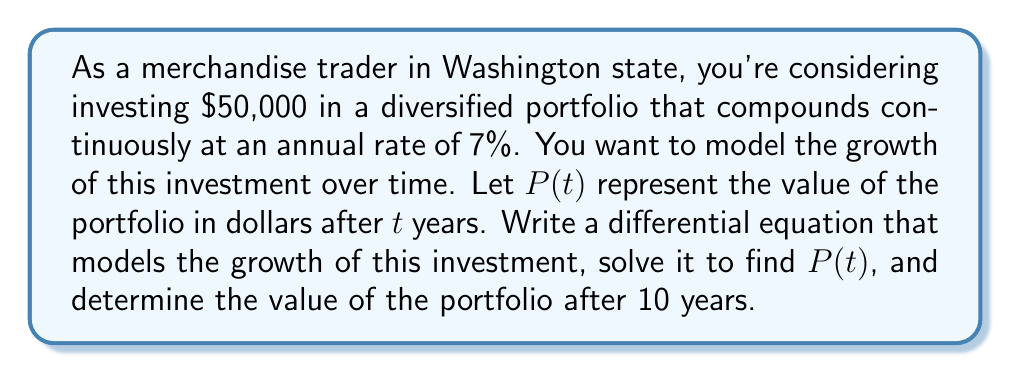Solve this math problem. To model the growth of an investment portfolio with compound interest, we use the following steps:

1) The rate of change of the portfolio value is proportional to the current value of the portfolio. This can be expressed as a differential equation:

   $$\frac{dP}{dt} = rP$$

   where $r$ is the annual interest rate expressed as a decimal.

2) In this case, $r = 0.07$ (7% annual rate), so our differential equation is:

   $$\frac{dP}{dt} = 0.07P$$

3) This is a separable differential equation. We can solve it by separating variables and integrating:

   $$\int \frac{dP}{P} = \int 0.07 dt$$

4) Integrating both sides:

   $$\ln|P| = 0.07t + C$$

   where $C$ is a constant of integration.

5) Exponentiating both sides:

   $$P = e^{0.07t + C} = e^C \cdot e^{0.07t}$$

6) Let $A = e^C$. Then our general solution is:

   $$P(t) = A \cdot e^{0.07t}$$

7) To find $A$, we use the initial condition. At $t = 0$, $P(0) = 50000$:

   $$50000 = A \cdot e^{0.07 \cdot 0} = A$$

8) Therefore, our particular solution is:

   $$P(t) = 50000 \cdot e^{0.07t}$$

9) To find the value after 10 years, we substitute $t = 10$:

   $$P(10) = 50000 \cdot e^{0.07 \cdot 10} = 50000 \cdot e^{0.7} \approx 101022.17$$
Answer: The differential equation modeling the growth is $\frac{dP}{dt} = 0.07P$. The solution is $P(t) = 50000 \cdot e^{0.07t}$. After 10 years, the portfolio value will be approximately $101,022.17. 